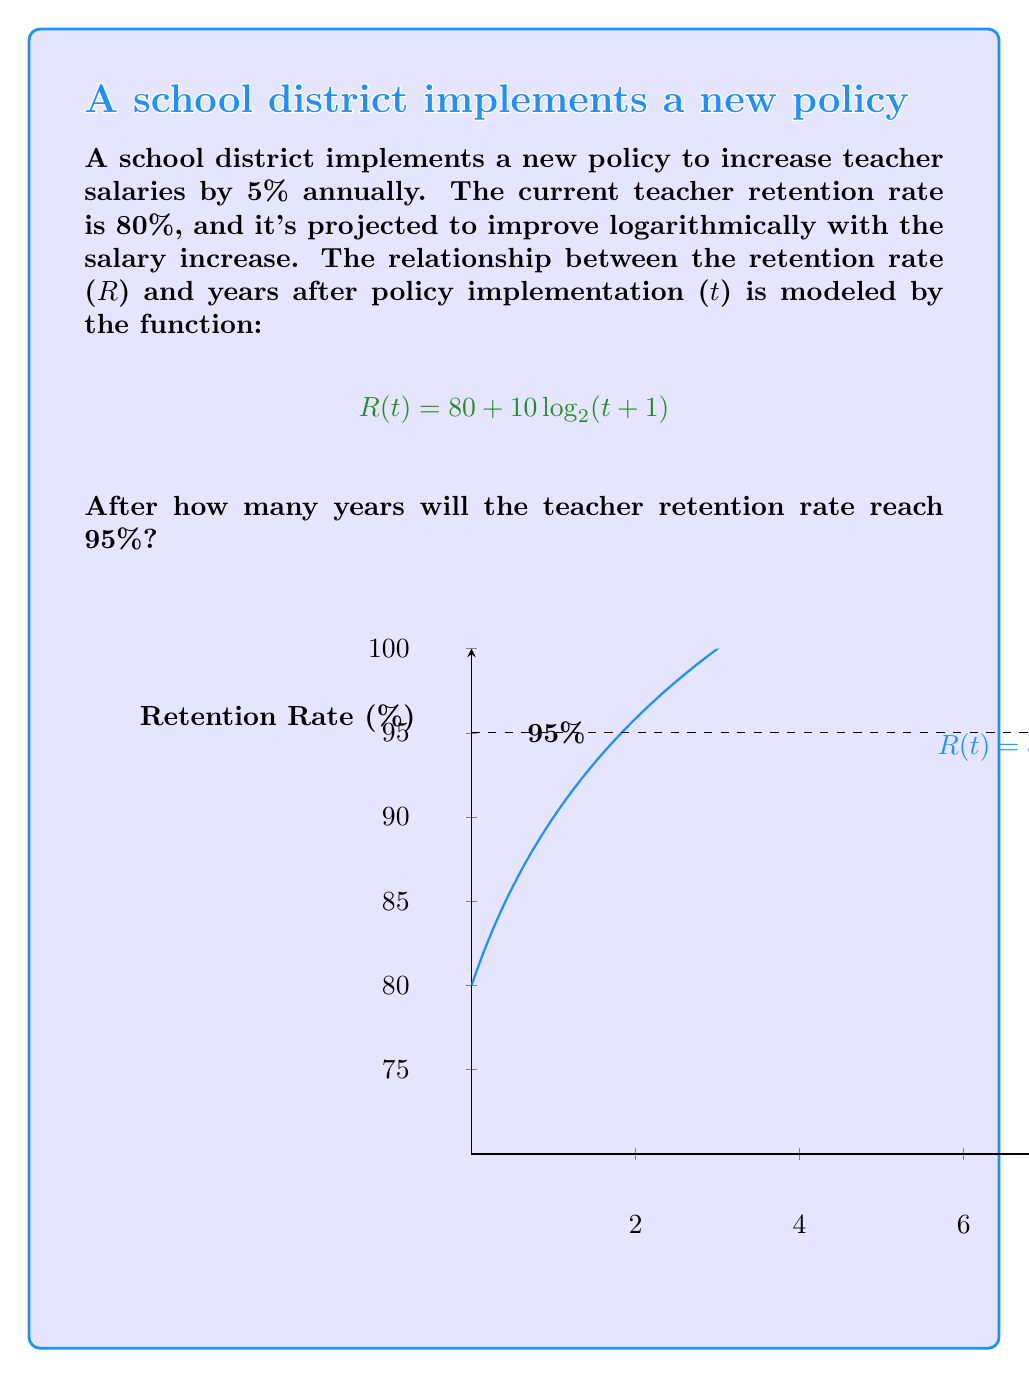Show me your answer to this math problem. To solve this problem, we need to follow these steps:

1) We want to find $t$ when $R(t) = 95$. So, we set up the equation:
   $$95 = 80 + 10 \log_2(t+1)$$

2) Subtract 80 from both sides:
   $$15 = 10 \log_2(t+1)$$

3) Divide both sides by 10:
   $$1.5 = \log_2(t+1)$$

4) To solve for $t$, we need to apply the inverse function (exponential) to both sides:
   $$2^{1.5} = t+1$$

5) Calculate $2^{1.5}$:
   $$2.8284 \approx t+1$$

6) Subtract 1 from both sides:
   $$1.8284 \approx t$$

7) Since we're dealing with years, we need to round up to the nearest whole number:
   $$t = 2$$

Therefore, it will take 2 years for the teacher retention rate to reach 95%.
Answer: 2 years 